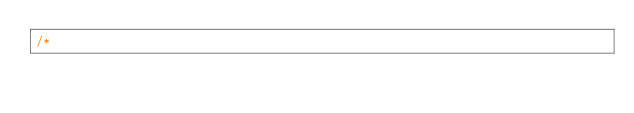Convert code to text. <code><loc_0><loc_0><loc_500><loc_500><_Cuda_>/*</code> 